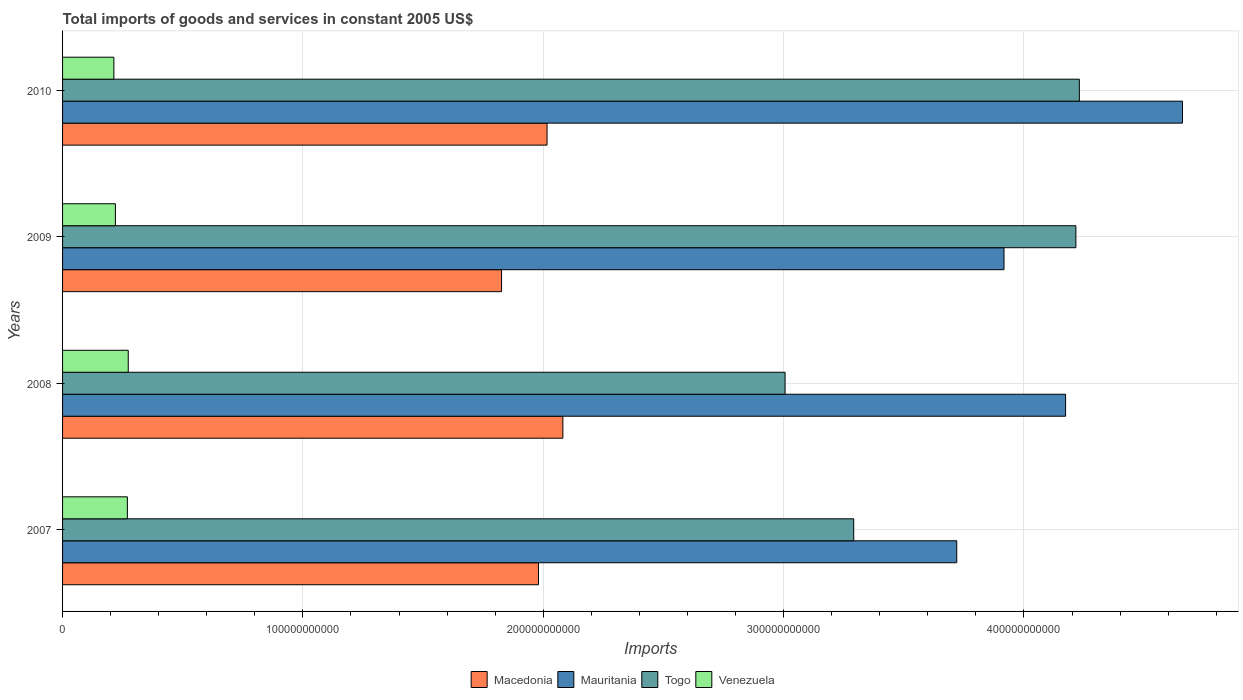How many groups of bars are there?
Your response must be concise. 4. Are the number of bars per tick equal to the number of legend labels?
Your answer should be very brief. Yes. Are the number of bars on each tick of the Y-axis equal?
Your response must be concise. Yes. What is the label of the 3rd group of bars from the top?
Offer a very short reply. 2008. What is the total imports of goods and services in Mauritania in 2010?
Offer a terse response. 4.66e+11. Across all years, what is the maximum total imports of goods and services in Togo?
Ensure brevity in your answer.  4.23e+11. Across all years, what is the minimum total imports of goods and services in Mauritania?
Offer a terse response. 3.72e+11. What is the total total imports of goods and services in Macedonia in the graph?
Provide a succinct answer. 7.90e+11. What is the difference between the total imports of goods and services in Venezuela in 2008 and that in 2010?
Your answer should be compact. 5.98e+09. What is the difference between the total imports of goods and services in Venezuela in 2009 and the total imports of goods and services in Togo in 2007?
Ensure brevity in your answer.  -3.07e+11. What is the average total imports of goods and services in Venezuela per year?
Your response must be concise. 2.44e+1. In the year 2008, what is the difference between the total imports of goods and services in Mauritania and total imports of goods and services in Venezuela?
Provide a succinct answer. 3.90e+11. In how many years, is the total imports of goods and services in Venezuela greater than 20000000000 US$?
Offer a terse response. 4. What is the ratio of the total imports of goods and services in Togo in 2007 to that in 2009?
Your answer should be very brief. 0.78. Is the total imports of goods and services in Mauritania in 2007 less than that in 2010?
Give a very brief answer. Yes. Is the difference between the total imports of goods and services in Mauritania in 2007 and 2009 greater than the difference between the total imports of goods and services in Venezuela in 2007 and 2009?
Give a very brief answer. No. What is the difference between the highest and the second highest total imports of goods and services in Togo?
Provide a short and direct response. 1.44e+09. What is the difference between the highest and the lowest total imports of goods and services in Macedonia?
Provide a succinct answer. 2.55e+1. Is the sum of the total imports of goods and services in Venezuela in 2007 and 2008 greater than the maximum total imports of goods and services in Mauritania across all years?
Provide a succinct answer. No. What does the 3rd bar from the top in 2010 represents?
Make the answer very short. Mauritania. What does the 4th bar from the bottom in 2010 represents?
Your answer should be very brief. Venezuela. How many bars are there?
Give a very brief answer. 16. What is the difference between two consecutive major ticks on the X-axis?
Offer a terse response. 1.00e+11. Where does the legend appear in the graph?
Provide a short and direct response. Bottom center. What is the title of the graph?
Offer a very short reply. Total imports of goods and services in constant 2005 US$. Does "North America" appear as one of the legend labels in the graph?
Your answer should be very brief. No. What is the label or title of the X-axis?
Your answer should be very brief. Imports. What is the label or title of the Y-axis?
Offer a terse response. Years. What is the Imports in Macedonia in 2007?
Ensure brevity in your answer.  1.98e+11. What is the Imports of Mauritania in 2007?
Your answer should be compact. 3.72e+11. What is the Imports in Togo in 2007?
Ensure brevity in your answer.  3.29e+11. What is the Imports of Venezuela in 2007?
Make the answer very short. 2.70e+1. What is the Imports in Macedonia in 2008?
Give a very brief answer. 2.08e+11. What is the Imports in Mauritania in 2008?
Offer a very short reply. 4.17e+11. What is the Imports in Togo in 2008?
Keep it short and to the point. 3.01e+11. What is the Imports of Venezuela in 2008?
Ensure brevity in your answer.  2.73e+1. What is the Imports in Macedonia in 2009?
Make the answer very short. 1.83e+11. What is the Imports in Mauritania in 2009?
Give a very brief answer. 3.92e+11. What is the Imports in Togo in 2009?
Provide a short and direct response. 4.22e+11. What is the Imports of Venezuela in 2009?
Your response must be concise. 2.20e+1. What is the Imports of Macedonia in 2010?
Your answer should be very brief. 2.02e+11. What is the Imports of Mauritania in 2010?
Offer a very short reply. 4.66e+11. What is the Imports of Togo in 2010?
Your response must be concise. 4.23e+11. What is the Imports of Venezuela in 2010?
Your response must be concise. 2.14e+1. Across all years, what is the maximum Imports in Macedonia?
Provide a short and direct response. 2.08e+11. Across all years, what is the maximum Imports in Mauritania?
Give a very brief answer. 4.66e+11. Across all years, what is the maximum Imports in Togo?
Make the answer very short. 4.23e+11. Across all years, what is the maximum Imports of Venezuela?
Ensure brevity in your answer.  2.73e+1. Across all years, what is the minimum Imports in Macedonia?
Offer a terse response. 1.83e+11. Across all years, what is the minimum Imports in Mauritania?
Offer a terse response. 3.72e+11. Across all years, what is the minimum Imports in Togo?
Offer a terse response. 3.01e+11. Across all years, what is the minimum Imports of Venezuela?
Offer a very short reply. 2.14e+1. What is the total Imports of Macedonia in the graph?
Offer a very short reply. 7.90e+11. What is the total Imports of Mauritania in the graph?
Give a very brief answer. 1.65e+12. What is the total Imports of Togo in the graph?
Make the answer very short. 1.47e+12. What is the total Imports of Venezuela in the graph?
Keep it short and to the point. 9.76e+1. What is the difference between the Imports of Macedonia in 2007 and that in 2008?
Give a very brief answer. -1.02e+1. What is the difference between the Imports in Mauritania in 2007 and that in 2008?
Your response must be concise. -4.53e+1. What is the difference between the Imports of Togo in 2007 and that in 2008?
Provide a short and direct response. 2.86e+1. What is the difference between the Imports in Venezuela in 2007 and that in 2008?
Provide a succinct answer. -3.67e+08. What is the difference between the Imports of Macedonia in 2007 and that in 2009?
Provide a short and direct response. 1.54e+1. What is the difference between the Imports of Mauritania in 2007 and that in 2009?
Make the answer very short. -1.97e+1. What is the difference between the Imports in Togo in 2007 and that in 2009?
Ensure brevity in your answer.  -9.24e+1. What is the difference between the Imports of Venezuela in 2007 and that in 2009?
Provide a short and direct response. 4.98e+09. What is the difference between the Imports of Macedonia in 2007 and that in 2010?
Provide a short and direct response. -3.57e+09. What is the difference between the Imports of Mauritania in 2007 and that in 2010?
Make the answer very short. -9.39e+1. What is the difference between the Imports of Togo in 2007 and that in 2010?
Provide a succinct answer. -9.39e+1. What is the difference between the Imports in Venezuela in 2007 and that in 2010?
Your answer should be compact. 5.61e+09. What is the difference between the Imports of Macedonia in 2008 and that in 2009?
Your response must be concise. 2.55e+1. What is the difference between the Imports of Mauritania in 2008 and that in 2009?
Ensure brevity in your answer.  2.56e+1. What is the difference between the Imports in Togo in 2008 and that in 2009?
Give a very brief answer. -1.21e+11. What is the difference between the Imports in Venezuela in 2008 and that in 2009?
Ensure brevity in your answer.  5.35e+09. What is the difference between the Imports in Macedonia in 2008 and that in 2010?
Keep it short and to the point. 6.58e+09. What is the difference between the Imports of Mauritania in 2008 and that in 2010?
Ensure brevity in your answer.  -4.86e+1. What is the difference between the Imports in Togo in 2008 and that in 2010?
Offer a terse response. -1.22e+11. What is the difference between the Imports of Venezuela in 2008 and that in 2010?
Give a very brief answer. 5.98e+09. What is the difference between the Imports in Macedonia in 2009 and that in 2010?
Provide a succinct answer. -1.89e+1. What is the difference between the Imports of Mauritania in 2009 and that in 2010?
Your response must be concise. -7.43e+1. What is the difference between the Imports in Togo in 2009 and that in 2010?
Your answer should be compact. -1.44e+09. What is the difference between the Imports in Venezuela in 2009 and that in 2010?
Ensure brevity in your answer.  6.36e+08. What is the difference between the Imports in Macedonia in 2007 and the Imports in Mauritania in 2008?
Your answer should be very brief. -2.19e+11. What is the difference between the Imports in Macedonia in 2007 and the Imports in Togo in 2008?
Offer a terse response. -1.03e+11. What is the difference between the Imports in Macedonia in 2007 and the Imports in Venezuela in 2008?
Your response must be concise. 1.71e+11. What is the difference between the Imports in Mauritania in 2007 and the Imports in Togo in 2008?
Ensure brevity in your answer.  7.14e+1. What is the difference between the Imports of Mauritania in 2007 and the Imports of Venezuela in 2008?
Your response must be concise. 3.45e+11. What is the difference between the Imports of Togo in 2007 and the Imports of Venezuela in 2008?
Give a very brief answer. 3.02e+11. What is the difference between the Imports of Macedonia in 2007 and the Imports of Mauritania in 2009?
Offer a terse response. -1.94e+11. What is the difference between the Imports in Macedonia in 2007 and the Imports in Togo in 2009?
Offer a very short reply. -2.24e+11. What is the difference between the Imports in Macedonia in 2007 and the Imports in Venezuela in 2009?
Your response must be concise. 1.76e+11. What is the difference between the Imports in Mauritania in 2007 and the Imports in Togo in 2009?
Offer a very short reply. -4.96e+1. What is the difference between the Imports in Mauritania in 2007 and the Imports in Venezuela in 2009?
Your answer should be very brief. 3.50e+11. What is the difference between the Imports in Togo in 2007 and the Imports in Venezuela in 2009?
Offer a terse response. 3.07e+11. What is the difference between the Imports in Macedonia in 2007 and the Imports in Mauritania in 2010?
Offer a terse response. -2.68e+11. What is the difference between the Imports of Macedonia in 2007 and the Imports of Togo in 2010?
Ensure brevity in your answer.  -2.25e+11. What is the difference between the Imports of Macedonia in 2007 and the Imports of Venezuela in 2010?
Give a very brief answer. 1.77e+11. What is the difference between the Imports of Mauritania in 2007 and the Imports of Togo in 2010?
Give a very brief answer. -5.10e+1. What is the difference between the Imports of Mauritania in 2007 and the Imports of Venezuela in 2010?
Keep it short and to the point. 3.51e+11. What is the difference between the Imports of Togo in 2007 and the Imports of Venezuela in 2010?
Provide a succinct answer. 3.08e+11. What is the difference between the Imports of Macedonia in 2008 and the Imports of Mauritania in 2009?
Your response must be concise. -1.84e+11. What is the difference between the Imports in Macedonia in 2008 and the Imports in Togo in 2009?
Give a very brief answer. -2.13e+11. What is the difference between the Imports of Macedonia in 2008 and the Imports of Venezuela in 2009?
Offer a terse response. 1.86e+11. What is the difference between the Imports of Mauritania in 2008 and the Imports of Togo in 2009?
Your response must be concise. -4.27e+09. What is the difference between the Imports in Mauritania in 2008 and the Imports in Venezuela in 2009?
Your answer should be very brief. 3.95e+11. What is the difference between the Imports of Togo in 2008 and the Imports of Venezuela in 2009?
Make the answer very short. 2.79e+11. What is the difference between the Imports of Macedonia in 2008 and the Imports of Mauritania in 2010?
Offer a terse response. -2.58e+11. What is the difference between the Imports of Macedonia in 2008 and the Imports of Togo in 2010?
Your answer should be very brief. -2.15e+11. What is the difference between the Imports in Macedonia in 2008 and the Imports in Venezuela in 2010?
Your answer should be compact. 1.87e+11. What is the difference between the Imports in Mauritania in 2008 and the Imports in Togo in 2010?
Ensure brevity in your answer.  -5.72e+09. What is the difference between the Imports in Mauritania in 2008 and the Imports in Venezuela in 2010?
Offer a terse response. 3.96e+11. What is the difference between the Imports of Togo in 2008 and the Imports of Venezuela in 2010?
Offer a terse response. 2.79e+11. What is the difference between the Imports in Macedonia in 2009 and the Imports in Mauritania in 2010?
Provide a short and direct response. -2.83e+11. What is the difference between the Imports in Macedonia in 2009 and the Imports in Togo in 2010?
Give a very brief answer. -2.40e+11. What is the difference between the Imports in Macedonia in 2009 and the Imports in Venezuela in 2010?
Offer a very short reply. 1.61e+11. What is the difference between the Imports in Mauritania in 2009 and the Imports in Togo in 2010?
Offer a very short reply. -3.13e+1. What is the difference between the Imports of Mauritania in 2009 and the Imports of Venezuela in 2010?
Ensure brevity in your answer.  3.70e+11. What is the difference between the Imports of Togo in 2009 and the Imports of Venezuela in 2010?
Keep it short and to the point. 4.00e+11. What is the average Imports of Macedonia per year?
Make the answer very short. 1.98e+11. What is the average Imports of Mauritania per year?
Provide a succinct answer. 4.12e+11. What is the average Imports in Togo per year?
Your response must be concise. 3.69e+11. What is the average Imports in Venezuela per year?
Offer a very short reply. 2.44e+1. In the year 2007, what is the difference between the Imports of Macedonia and Imports of Mauritania?
Your response must be concise. -1.74e+11. In the year 2007, what is the difference between the Imports in Macedonia and Imports in Togo?
Keep it short and to the point. -1.31e+11. In the year 2007, what is the difference between the Imports of Macedonia and Imports of Venezuela?
Give a very brief answer. 1.71e+11. In the year 2007, what is the difference between the Imports in Mauritania and Imports in Togo?
Offer a very short reply. 4.29e+1. In the year 2007, what is the difference between the Imports of Mauritania and Imports of Venezuela?
Ensure brevity in your answer.  3.45e+11. In the year 2007, what is the difference between the Imports in Togo and Imports in Venezuela?
Offer a very short reply. 3.02e+11. In the year 2008, what is the difference between the Imports in Macedonia and Imports in Mauritania?
Your response must be concise. -2.09e+11. In the year 2008, what is the difference between the Imports of Macedonia and Imports of Togo?
Give a very brief answer. -9.24e+1. In the year 2008, what is the difference between the Imports of Macedonia and Imports of Venezuela?
Your response must be concise. 1.81e+11. In the year 2008, what is the difference between the Imports of Mauritania and Imports of Togo?
Keep it short and to the point. 1.17e+11. In the year 2008, what is the difference between the Imports in Mauritania and Imports in Venezuela?
Give a very brief answer. 3.90e+11. In the year 2008, what is the difference between the Imports of Togo and Imports of Venezuela?
Your answer should be very brief. 2.73e+11. In the year 2009, what is the difference between the Imports in Macedonia and Imports in Mauritania?
Offer a very short reply. -2.09e+11. In the year 2009, what is the difference between the Imports in Macedonia and Imports in Togo?
Your answer should be very brief. -2.39e+11. In the year 2009, what is the difference between the Imports in Macedonia and Imports in Venezuela?
Your answer should be compact. 1.61e+11. In the year 2009, what is the difference between the Imports of Mauritania and Imports of Togo?
Ensure brevity in your answer.  -2.99e+1. In the year 2009, what is the difference between the Imports of Mauritania and Imports of Venezuela?
Give a very brief answer. 3.70e+11. In the year 2009, what is the difference between the Imports in Togo and Imports in Venezuela?
Your answer should be very brief. 4.00e+11. In the year 2010, what is the difference between the Imports in Macedonia and Imports in Mauritania?
Your answer should be compact. -2.64e+11. In the year 2010, what is the difference between the Imports in Macedonia and Imports in Togo?
Keep it short and to the point. -2.21e+11. In the year 2010, what is the difference between the Imports in Macedonia and Imports in Venezuela?
Your answer should be compact. 1.80e+11. In the year 2010, what is the difference between the Imports of Mauritania and Imports of Togo?
Your response must be concise. 4.29e+1. In the year 2010, what is the difference between the Imports in Mauritania and Imports in Venezuela?
Provide a short and direct response. 4.45e+11. In the year 2010, what is the difference between the Imports of Togo and Imports of Venezuela?
Ensure brevity in your answer.  4.02e+11. What is the ratio of the Imports in Macedonia in 2007 to that in 2008?
Make the answer very short. 0.95. What is the ratio of the Imports in Mauritania in 2007 to that in 2008?
Your response must be concise. 0.89. What is the ratio of the Imports in Togo in 2007 to that in 2008?
Keep it short and to the point. 1.09. What is the ratio of the Imports of Venezuela in 2007 to that in 2008?
Ensure brevity in your answer.  0.99. What is the ratio of the Imports in Macedonia in 2007 to that in 2009?
Make the answer very short. 1.08. What is the ratio of the Imports in Mauritania in 2007 to that in 2009?
Give a very brief answer. 0.95. What is the ratio of the Imports of Togo in 2007 to that in 2009?
Make the answer very short. 0.78. What is the ratio of the Imports in Venezuela in 2007 to that in 2009?
Offer a terse response. 1.23. What is the ratio of the Imports of Macedonia in 2007 to that in 2010?
Your answer should be compact. 0.98. What is the ratio of the Imports in Mauritania in 2007 to that in 2010?
Provide a succinct answer. 0.8. What is the ratio of the Imports of Togo in 2007 to that in 2010?
Give a very brief answer. 0.78. What is the ratio of the Imports in Venezuela in 2007 to that in 2010?
Offer a very short reply. 1.26. What is the ratio of the Imports of Macedonia in 2008 to that in 2009?
Offer a very short reply. 1.14. What is the ratio of the Imports in Mauritania in 2008 to that in 2009?
Your answer should be compact. 1.07. What is the ratio of the Imports of Togo in 2008 to that in 2009?
Your answer should be very brief. 0.71. What is the ratio of the Imports in Venezuela in 2008 to that in 2009?
Ensure brevity in your answer.  1.24. What is the ratio of the Imports in Macedonia in 2008 to that in 2010?
Provide a short and direct response. 1.03. What is the ratio of the Imports of Mauritania in 2008 to that in 2010?
Make the answer very short. 0.9. What is the ratio of the Imports in Togo in 2008 to that in 2010?
Your answer should be compact. 0.71. What is the ratio of the Imports in Venezuela in 2008 to that in 2010?
Keep it short and to the point. 1.28. What is the ratio of the Imports in Macedonia in 2009 to that in 2010?
Give a very brief answer. 0.91. What is the ratio of the Imports in Mauritania in 2009 to that in 2010?
Ensure brevity in your answer.  0.84. What is the ratio of the Imports in Venezuela in 2009 to that in 2010?
Ensure brevity in your answer.  1.03. What is the difference between the highest and the second highest Imports in Macedonia?
Your response must be concise. 6.58e+09. What is the difference between the highest and the second highest Imports in Mauritania?
Give a very brief answer. 4.86e+1. What is the difference between the highest and the second highest Imports in Togo?
Ensure brevity in your answer.  1.44e+09. What is the difference between the highest and the second highest Imports in Venezuela?
Make the answer very short. 3.67e+08. What is the difference between the highest and the lowest Imports in Macedonia?
Offer a terse response. 2.55e+1. What is the difference between the highest and the lowest Imports in Mauritania?
Provide a short and direct response. 9.39e+1. What is the difference between the highest and the lowest Imports in Togo?
Offer a terse response. 1.22e+11. What is the difference between the highest and the lowest Imports in Venezuela?
Your answer should be very brief. 5.98e+09. 